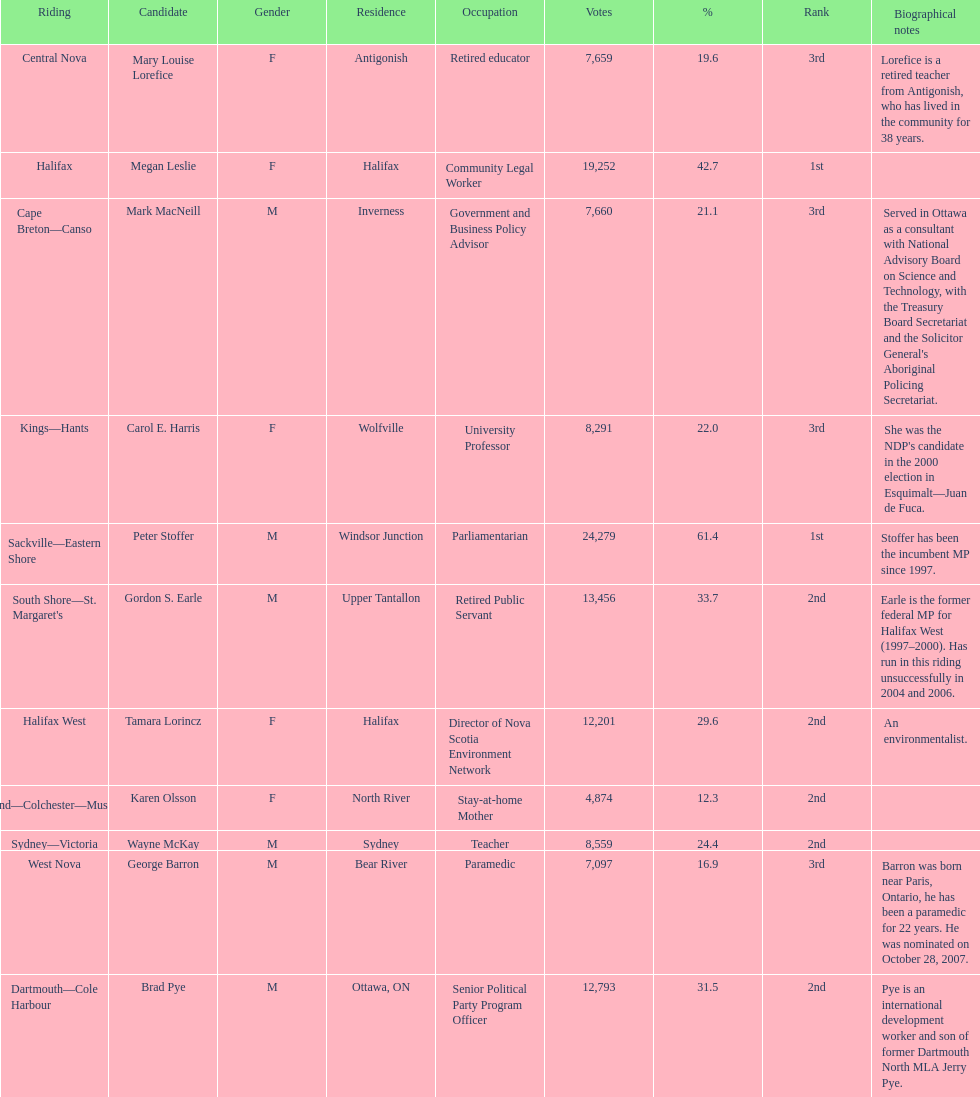Who has the most votes? Sackville-Eastern Shore. 